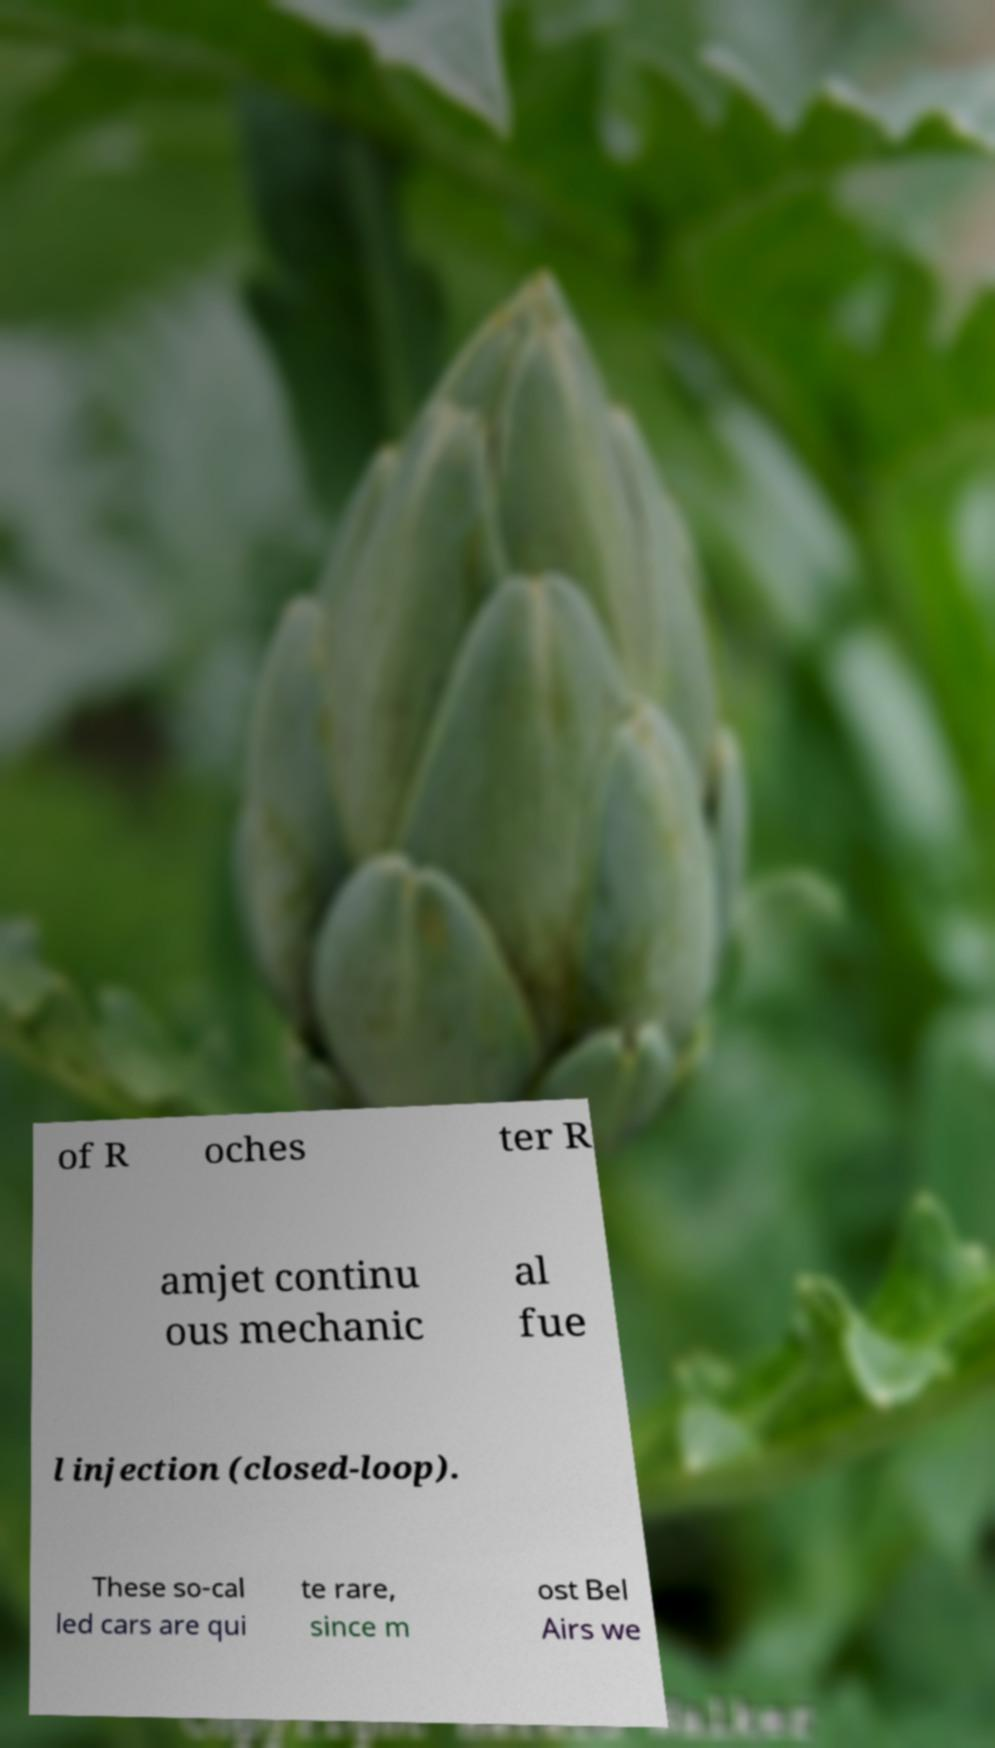For documentation purposes, I need the text within this image transcribed. Could you provide that? of R oches ter R amjet continu ous mechanic al fue l injection (closed-loop). These so-cal led cars are qui te rare, since m ost Bel Airs we 